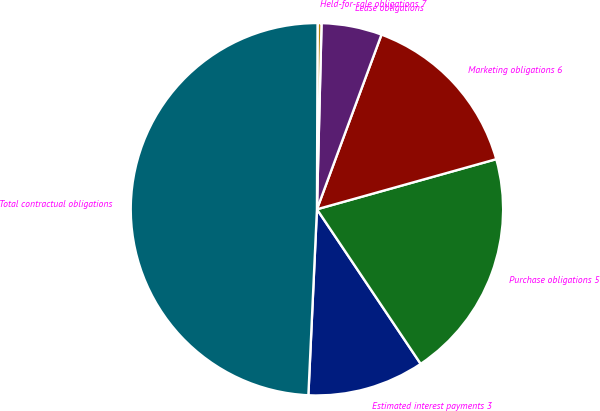Convert chart to OTSL. <chart><loc_0><loc_0><loc_500><loc_500><pie_chart><fcel>Estimated interest payments 3<fcel>Purchase obligations 5<fcel>Marketing obligations 6<fcel>Lease obligations<fcel>Held-for-sale obligations 7<fcel>Total contractual obligations<nl><fcel>10.14%<fcel>19.93%<fcel>15.03%<fcel>5.24%<fcel>0.34%<fcel>49.32%<nl></chart> 